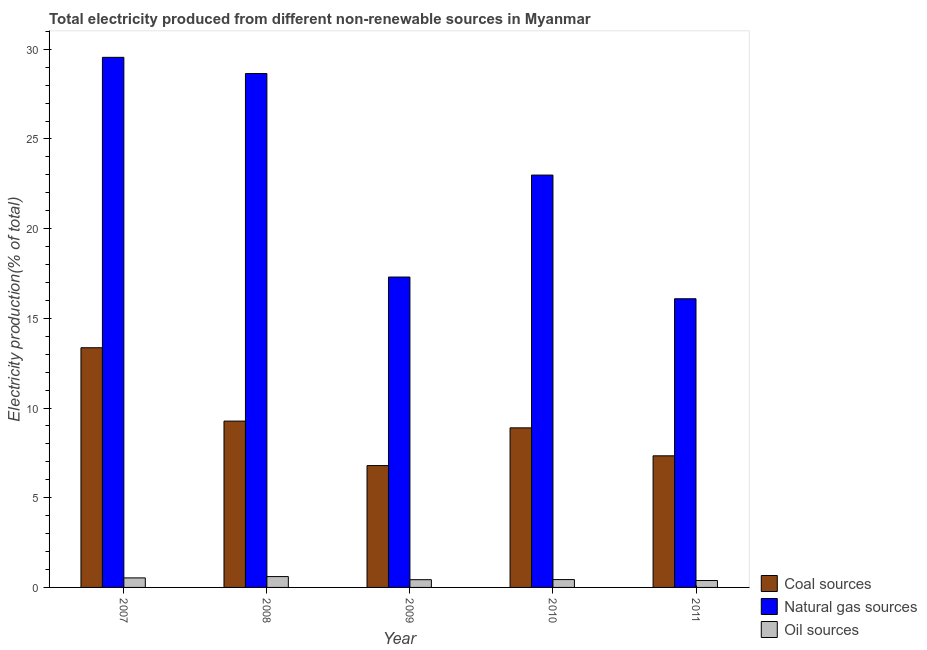Are the number of bars per tick equal to the number of legend labels?
Ensure brevity in your answer.  Yes. Are the number of bars on each tick of the X-axis equal?
Provide a short and direct response. Yes. What is the label of the 1st group of bars from the left?
Your response must be concise. 2007. What is the percentage of electricity produced by oil sources in 2009?
Provide a short and direct response. 0.43. Across all years, what is the maximum percentage of electricity produced by coal?
Offer a terse response. 13.36. Across all years, what is the minimum percentage of electricity produced by natural gas?
Make the answer very short. 16.09. In which year was the percentage of electricity produced by oil sources maximum?
Your response must be concise. 2008. In which year was the percentage of electricity produced by oil sources minimum?
Offer a terse response. 2011. What is the total percentage of electricity produced by oil sources in the graph?
Your response must be concise. 2.39. What is the difference between the percentage of electricity produced by natural gas in 2007 and that in 2010?
Keep it short and to the point. 6.56. What is the difference between the percentage of electricity produced by natural gas in 2010 and the percentage of electricity produced by oil sources in 2008?
Make the answer very short. -5.66. What is the average percentage of electricity produced by oil sources per year?
Your answer should be very brief. 0.48. What is the ratio of the percentage of electricity produced by natural gas in 2007 to that in 2008?
Offer a very short reply. 1.03. Is the difference between the percentage of electricity produced by oil sources in 2007 and 2011 greater than the difference between the percentage of electricity produced by natural gas in 2007 and 2011?
Keep it short and to the point. No. What is the difference between the highest and the second highest percentage of electricity produced by oil sources?
Provide a short and direct response. 0.07. What is the difference between the highest and the lowest percentage of electricity produced by oil sources?
Offer a very short reply. 0.22. In how many years, is the percentage of electricity produced by natural gas greater than the average percentage of electricity produced by natural gas taken over all years?
Your answer should be compact. 3. Is the sum of the percentage of electricity produced by coal in 2008 and 2009 greater than the maximum percentage of electricity produced by oil sources across all years?
Your response must be concise. Yes. What does the 3rd bar from the left in 2007 represents?
Offer a very short reply. Oil sources. What does the 2nd bar from the right in 2011 represents?
Keep it short and to the point. Natural gas sources. Is it the case that in every year, the sum of the percentage of electricity produced by coal and percentage of electricity produced by natural gas is greater than the percentage of electricity produced by oil sources?
Your response must be concise. Yes. How many years are there in the graph?
Offer a terse response. 5. Are the values on the major ticks of Y-axis written in scientific E-notation?
Your answer should be very brief. No. How many legend labels are there?
Give a very brief answer. 3. How are the legend labels stacked?
Your answer should be compact. Vertical. What is the title of the graph?
Keep it short and to the point. Total electricity produced from different non-renewable sources in Myanmar. Does "Domestic" appear as one of the legend labels in the graph?
Your answer should be compact. No. What is the Electricity production(% of total) of Coal sources in 2007?
Your answer should be very brief. 13.36. What is the Electricity production(% of total) of Natural gas sources in 2007?
Make the answer very short. 29.55. What is the Electricity production(% of total) in Oil sources in 2007?
Give a very brief answer. 0.53. What is the Electricity production(% of total) in Coal sources in 2008?
Give a very brief answer. 9.27. What is the Electricity production(% of total) in Natural gas sources in 2008?
Your response must be concise. 28.65. What is the Electricity production(% of total) of Oil sources in 2008?
Your answer should be compact. 0.6. What is the Electricity production(% of total) of Coal sources in 2009?
Your answer should be very brief. 6.79. What is the Electricity production(% of total) of Natural gas sources in 2009?
Your answer should be compact. 17.3. What is the Electricity production(% of total) in Oil sources in 2009?
Provide a short and direct response. 0.43. What is the Electricity production(% of total) in Coal sources in 2010?
Your response must be concise. 8.9. What is the Electricity production(% of total) of Natural gas sources in 2010?
Your answer should be very brief. 22.99. What is the Electricity production(% of total) of Oil sources in 2010?
Give a very brief answer. 0.44. What is the Electricity production(% of total) of Coal sources in 2011?
Your answer should be very brief. 7.34. What is the Electricity production(% of total) in Natural gas sources in 2011?
Offer a terse response. 16.09. What is the Electricity production(% of total) of Oil sources in 2011?
Your answer should be very brief. 0.39. Across all years, what is the maximum Electricity production(% of total) of Coal sources?
Make the answer very short. 13.36. Across all years, what is the maximum Electricity production(% of total) in Natural gas sources?
Provide a short and direct response. 29.55. Across all years, what is the maximum Electricity production(% of total) in Oil sources?
Your answer should be compact. 0.6. Across all years, what is the minimum Electricity production(% of total) of Coal sources?
Provide a short and direct response. 6.79. Across all years, what is the minimum Electricity production(% of total) in Natural gas sources?
Offer a very short reply. 16.09. Across all years, what is the minimum Electricity production(% of total) in Oil sources?
Your response must be concise. 0.39. What is the total Electricity production(% of total) in Coal sources in the graph?
Ensure brevity in your answer.  45.66. What is the total Electricity production(% of total) in Natural gas sources in the graph?
Keep it short and to the point. 114.58. What is the total Electricity production(% of total) of Oil sources in the graph?
Your answer should be very brief. 2.39. What is the difference between the Electricity production(% of total) of Coal sources in 2007 and that in 2008?
Provide a short and direct response. 4.09. What is the difference between the Electricity production(% of total) in Natural gas sources in 2007 and that in 2008?
Your answer should be compact. 0.9. What is the difference between the Electricity production(% of total) of Oil sources in 2007 and that in 2008?
Ensure brevity in your answer.  -0.07. What is the difference between the Electricity production(% of total) in Coal sources in 2007 and that in 2009?
Offer a terse response. 6.57. What is the difference between the Electricity production(% of total) of Natural gas sources in 2007 and that in 2009?
Make the answer very short. 12.25. What is the difference between the Electricity production(% of total) in Oil sources in 2007 and that in 2009?
Keep it short and to the point. 0.1. What is the difference between the Electricity production(% of total) in Coal sources in 2007 and that in 2010?
Offer a very short reply. 4.47. What is the difference between the Electricity production(% of total) of Natural gas sources in 2007 and that in 2010?
Provide a succinct answer. 6.56. What is the difference between the Electricity production(% of total) in Oil sources in 2007 and that in 2010?
Provide a short and direct response. 0.09. What is the difference between the Electricity production(% of total) in Coal sources in 2007 and that in 2011?
Your answer should be very brief. 6.02. What is the difference between the Electricity production(% of total) in Natural gas sources in 2007 and that in 2011?
Offer a terse response. 13.46. What is the difference between the Electricity production(% of total) in Oil sources in 2007 and that in 2011?
Offer a very short reply. 0.15. What is the difference between the Electricity production(% of total) of Coal sources in 2008 and that in 2009?
Provide a succinct answer. 2.48. What is the difference between the Electricity production(% of total) of Natural gas sources in 2008 and that in 2009?
Provide a succinct answer. 11.34. What is the difference between the Electricity production(% of total) in Oil sources in 2008 and that in 2009?
Ensure brevity in your answer.  0.17. What is the difference between the Electricity production(% of total) of Coal sources in 2008 and that in 2010?
Your answer should be very brief. 0.38. What is the difference between the Electricity production(% of total) of Natural gas sources in 2008 and that in 2010?
Provide a short and direct response. 5.66. What is the difference between the Electricity production(% of total) of Oil sources in 2008 and that in 2010?
Provide a succinct answer. 0.17. What is the difference between the Electricity production(% of total) of Coal sources in 2008 and that in 2011?
Your answer should be very brief. 1.94. What is the difference between the Electricity production(% of total) in Natural gas sources in 2008 and that in 2011?
Ensure brevity in your answer.  12.55. What is the difference between the Electricity production(% of total) in Oil sources in 2008 and that in 2011?
Make the answer very short. 0.22. What is the difference between the Electricity production(% of total) of Coal sources in 2009 and that in 2010?
Your response must be concise. -2.1. What is the difference between the Electricity production(% of total) of Natural gas sources in 2009 and that in 2010?
Your answer should be very brief. -5.68. What is the difference between the Electricity production(% of total) in Oil sources in 2009 and that in 2010?
Offer a terse response. -0.01. What is the difference between the Electricity production(% of total) of Coal sources in 2009 and that in 2011?
Ensure brevity in your answer.  -0.54. What is the difference between the Electricity production(% of total) of Natural gas sources in 2009 and that in 2011?
Ensure brevity in your answer.  1.21. What is the difference between the Electricity production(% of total) of Oil sources in 2009 and that in 2011?
Your answer should be compact. 0.05. What is the difference between the Electricity production(% of total) of Coal sources in 2010 and that in 2011?
Offer a terse response. 1.56. What is the difference between the Electricity production(% of total) in Natural gas sources in 2010 and that in 2011?
Your response must be concise. 6.9. What is the difference between the Electricity production(% of total) in Oil sources in 2010 and that in 2011?
Your answer should be very brief. 0.05. What is the difference between the Electricity production(% of total) of Coal sources in 2007 and the Electricity production(% of total) of Natural gas sources in 2008?
Your response must be concise. -15.29. What is the difference between the Electricity production(% of total) in Coal sources in 2007 and the Electricity production(% of total) in Oil sources in 2008?
Provide a short and direct response. 12.76. What is the difference between the Electricity production(% of total) in Natural gas sources in 2007 and the Electricity production(% of total) in Oil sources in 2008?
Provide a succinct answer. 28.95. What is the difference between the Electricity production(% of total) of Coal sources in 2007 and the Electricity production(% of total) of Natural gas sources in 2009?
Keep it short and to the point. -3.94. What is the difference between the Electricity production(% of total) of Coal sources in 2007 and the Electricity production(% of total) of Oil sources in 2009?
Offer a terse response. 12.93. What is the difference between the Electricity production(% of total) in Natural gas sources in 2007 and the Electricity production(% of total) in Oil sources in 2009?
Give a very brief answer. 29.12. What is the difference between the Electricity production(% of total) of Coal sources in 2007 and the Electricity production(% of total) of Natural gas sources in 2010?
Give a very brief answer. -9.63. What is the difference between the Electricity production(% of total) of Coal sources in 2007 and the Electricity production(% of total) of Oil sources in 2010?
Offer a very short reply. 12.92. What is the difference between the Electricity production(% of total) of Natural gas sources in 2007 and the Electricity production(% of total) of Oil sources in 2010?
Offer a terse response. 29.11. What is the difference between the Electricity production(% of total) in Coal sources in 2007 and the Electricity production(% of total) in Natural gas sources in 2011?
Make the answer very short. -2.73. What is the difference between the Electricity production(% of total) in Coal sources in 2007 and the Electricity production(% of total) in Oil sources in 2011?
Your answer should be very brief. 12.98. What is the difference between the Electricity production(% of total) of Natural gas sources in 2007 and the Electricity production(% of total) of Oil sources in 2011?
Your response must be concise. 29.17. What is the difference between the Electricity production(% of total) in Coal sources in 2008 and the Electricity production(% of total) in Natural gas sources in 2009?
Give a very brief answer. -8.03. What is the difference between the Electricity production(% of total) in Coal sources in 2008 and the Electricity production(% of total) in Oil sources in 2009?
Keep it short and to the point. 8.84. What is the difference between the Electricity production(% of total) in Natural gas sources in 2008 and the Electricity production(% of total) in Oil sources in 2009?
Make the answer very short. 28.22. What is the difference between the Electricity production(% of total) in Coal sources in 2008 and the Electricity production(% of total) in Natural gas sources in 2010?
Your answer should be very brief. -13.72. What is the difference between the Electricity production(% of total) of Coal sources in 2008 and the Electricity production(% of total) of Oil sources in 2010?
Ensure brevity in your answer.  8.83. What is the difference between the Electricity production(% of total) in Natural gas sources in 2008 and the Electricity production(% of total) in Oil sources in 2010?
Your answer should be very brief. 28.21. What is the difference between the Electricity production(% of total) of Coal sources in 2008 and the Electricity production(% of total) of Natural gas sources in 2011?
Your answer should be compact. -6.82. What is the difference between the Electricity production(% of total) in Coal sources in 2008 and the Electricity production(% of total) in Oil sources in 2011?
Provide a succinct answer. 8.89. What is the difference between the Electricity production(% of total) in Natural gas sources in 2008 and the Electricity production(% of total) in Oil sources in 2011?
Provide a short and direct response. 28.26. What is the difference between the Electricity production(% of total) of Coal sources in 2009 and the Electricity production(% of total) of Natural gas sources in 2010?
Keep it short and to the point. -16.2. What is the difference between the Electricity production(% of total) in Coal sources in 2009 and the Electricity production(% of total) in Oil sources in 2010?
Your response must be concise. 6.35. What is the difference between the Electricity production(% of total) of Natural gas sources in 2009 and the Electricity production(% of total) of Oil sources in 2010?
Provide a succinct answer. 16.87. What is the difference between the Electricity production(% of total) of Coal sources in 2009 and the Electricity production(% of total) of Natural gas sources in 2011?
Make the answer very short. -9.3. What is the difference between the Electricity production(% of total) in Coal sources in 2009 and the Electricity production(% of total) in Oil sources in 2011?
Keep it short and to the point. 6.41. What is the difference between the Electricity production(% of total) in Natural gas sources in 2009 and the Electricity production(% of total) in Oil sources in 2011?
Your answer should be very brief. 16.92. What is the difference between the Electricity production(% of total) of Coal sources in 2010 and the Electricity production(% of total) of Natural gas sources in 2011?
Make the answer very short. -7.2. What is the difference between the Electricity production(% of total) of Coal sources in 2010 and the Electricity production(% of total) of Oil sources in 2011?
Provide a succinct answer. 8.51. What is the difference between the Electricity production(% of total) in Natural gas sources in 2010 and the Electricity production(% of total) in Oil sources in 2011?
Provide a short and direct response. 22.6. What is the average Electricity production(% of total) of Coal sources per year?
Keep it short and to the point. 9.13. What is the average Electricity production(% of total) of Natural gas sources per year?
Provide a short and direct response. 22.92. What is the average Electricity production(% of total) in Oil sources per year?
Make the answer very short. 0.48. In the year 2007, what is the difference between the Electricity production(% of total) of Coal sources and Electricity production(% of total) of Natural gas sources?
Keep it short and to the point. -16.19. In the year 2007, what is the difference between the Electricity production(% of total) of Coal sources and Electricity production(% of total) of Oil sources?
Ensure brevity in your answer.  12.83. In the year 2007, what is the difference between the Electricity production(% of total) in Natural gas sources and Electricity production(% of total) in Oil sources?
Provide a succinct answer. 29.02. In the year 2008, what is the difference between the Electricity production(% of total) in Coal sources and Electricity production(% of total) in Natural gas sources?
Offer a very short reply. -19.37. In the year 2008, what is the difference between the Electricity production(% of total) in Coal sources and Electricity production(% of total) in Oil sources?
Offer a terse response. 8.67. In the year 2008, what is the difference between the Electricity production(% of total) of Natural gas sources and Electricity production(% of total) of Oil sources?
Your answer should be very brief. 28.04. In the year 2009, what is the difference between the Electricity production(% of total) of Coal sources and Electricity production(% of total) of Natural gas sources?
Keep it short and to the point. -10.51. In the year 2009, what is the difference between the Electricity production(% of total) in Coal sources and Electricity production(% of total) in Oil sources?
Offer a terse response. 6.36. In the year 2009, what is the difference between the Electricity production(% of total) of Natural gas sources and Electricity production(% of total) of Oil sources?
Your answer should be compact. 16.87. In the year 2010, what is the difference between the Electricity production(% of total) in Coal sources and Electricity production(% of total) in Natural gas sources?
Provide a short and direct response. -14.09. In the year 2010, what is the difference between the Electricity production(% of total) in Coal sources and Electricity production(% of total) in Oil sources?
Your answer should be compact. 8.46. In the year 2010, what is the difference between the Electricity production(% of total) in Natural gas sources and Electricity production(% of total) in Oil sources?
Offer a very short reply. 22.55. In the year 2011, what is the difference between the Electricity production(% of total) of Coal sources and Electricity production(% of total) of Natural gas sources?
Offer a very short reply. -8.76. In the year 2011, what is the difference between the Electricity production(% of total) in Coal sources and Electricity production(% of total) in Oil sources?
Provide a short and direct response. 6.95. In the year 2011, what is the difference between the Electricity production(% of total) of Natural gas sources and Electricity production(% of total) of Oil sources?
Offer a very short reply. 15.71. What is the ratio of the Electricity production(% of total) of Coal sources in 2007 to that in 2008?
Keep it short and to the point. 1.44. What is the ratio of the Electricity production(% of total) in Natural gas sources in 2007 to that in 2008?
Give a very brief answer. 1.03. What is the ratio of the Electricity production(% of total) of Oil sources in 2007 to that in 2008?
Your answer should be compact. 0.88. What is the ratio of the Electricity production(% of total) of Coal sources in 2007 to that in 2009?
Your response must be concise. 1.97. What is the ratio of the Electricity production(% of total) of Natural gas sources in 2007 to that in 2009?
Provide a short and direct response. 1.71. What is the ratio of the Electricity production(% of total) of Oil sources in 2007 to that in 2009?
Provide a succinct answer. 1.23. What is the ratio of the Electricity production(% of total) of Coal sources in 2007 to that in 2010?
Your answer should be very brief. 1.5. What is the ratio of the Electricity production(% of total) of Natural gas sources in 2007 to that in 2010?
Provide a succinct answer. 1.29. What is the ratio of the Electricity production(% of total) of Oil sources in 2007 to that in 2010?
Make the answer very short. 1.21. What is the ratio of the Electricity production(% of total) in Coal sources in 2007 to that in 2011?
Give a very brief answer. 1.82. What is the ratio of the Electricity production(% of total) in Natural gas sources in 2007 to that in 2011?
Make the answer very short. 1.84. What is the ratio of the Electricity production(% of total) of Oil sources in 2007 to that in 2011?
Make the answer very short. 1.38. What is the ratio of the Electricity production(% of total) of Coal sources in 2008 to that in 2009?
Keep it short and to the point. 1.37. What is the ratio of the Electricity production(% of total) in Natural gas sources in 2008 to that in 2009?
Provide a short and direct response. 1.66. What is the ratio of the Electricity production(% of total) in Oil sources in 2008 to that in 2009?
Give a very brief answer. 1.4. What is the ratio of the Electricity production(% of total) in Coal sources in 2008 to that in 2010?
Offer a terse response. 1.04. What is the ratio of the Electricity production(% of total) of Natural gas sources in 2008 to that in 2010?
Offer a terse response. 1.25. What is the ratio of the Electricity production(% of total) in Oil sources in 2008 to that in 2010?
Give a very brief answer. 1.38. What is the ratio of the Electricity production(% of total) of Coal sources in 2008 to that in 2011?
Make the answer very short. 1.26. What is the ratio of the Electricity production(% of total) in Natural gas sources in 2008 to that in 2011?
Give a very brief answer. 1.78. What is the ratio of the Electricity production(% of total) of Oil sources in 2008 to that in 2011?
Your response must be concise. 1.57. What is the ratio of the Electricity production(% of total) in Coal sources in 2009 to that in 2010?
Your response must be concise. 0.76. What is the ratio of the Electricity production(% of total) in Natural gas sources in 2009 to that in 2010?
Your answer should be very brief. 0.75. What is the ratio of the Electricity production(% of total) in Oil sources in 2009 to that in 2010?
Your answer should be compact. 0.98. What is the ratio of the Electricity production(% of total) of Coal sources in 2009 to that in 2011?
Make the answer very short. 0.93. What is the ratio of the Electricity production(% of total) in Natural gas sources in 2009 to that in 2011?
Offer a very short reply. 1.08. What is the ratio of the Electricity production(% of total) in Oil sources in 2009 to that in 2011?
Your response must be concise. 1.12. What is the ratio of the Electricity production(% of total) of Coal sources in 2010 to that in 2011?
Offer a very short reply. 1.21. What is the ratio of the Electricity production(% of total) in Natural gas sources in 2010 to that in 2011?
Provide a short and direct response. 1.43. What is the ratio of the Electricity production(% of total) of Oil sources in 2010 to that in 2011?
Your answer should be very brief. 1.14. What is the difference between the highest and the second highest Electricity production(% of total) of Coal sources?
Make the answer very short. 4.09. What is the difference between the highest and the second highest Electricity production(% of total) of Natural gas sources?
Offer a very short reply. 0.9. What is the difference between the highest and the second highest Electricity production(% of total) in Oil sources?
Provide a succinct answer. 0.07. What is the difference between the highest and the lowest Electricity production(% of total) in Coal sources?
Your answer should be compact. 6.57. What is the difference between the highest and the lowest Electricity production(% of total) in Natural gas sources?
Ensure brevity in your answer.  13.46. What is the difference between the highest and the lowest Electricity production(% of total) in Oil sources?
Your answer should be very brief. 0.22. 